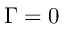<formula> <loc_0><loc_0><loc_500><loc_500>\Gamma = 0</formula> 